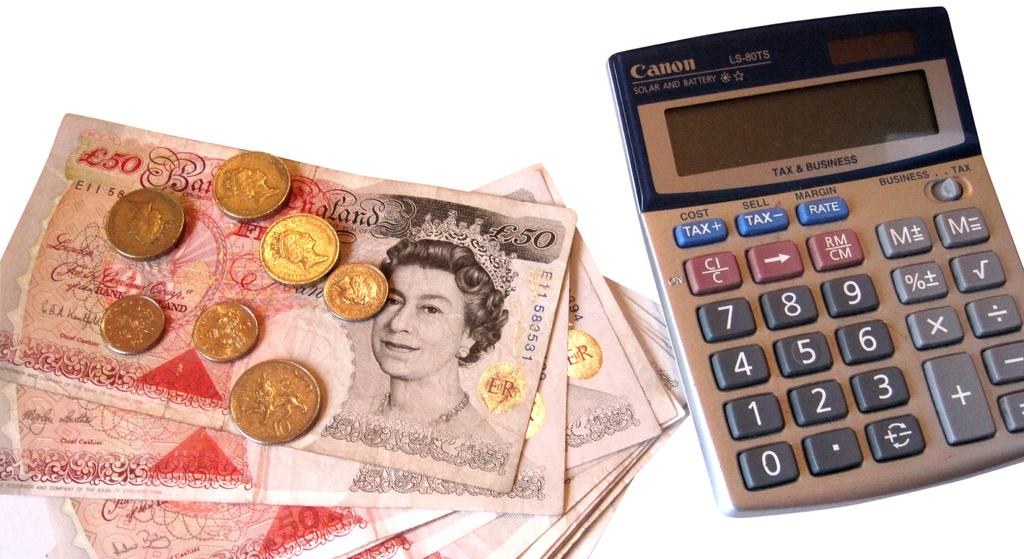<image>
Write a terse but informative summary of the picture. A stack of fifty pond notes and some coins next to a digital calculator 